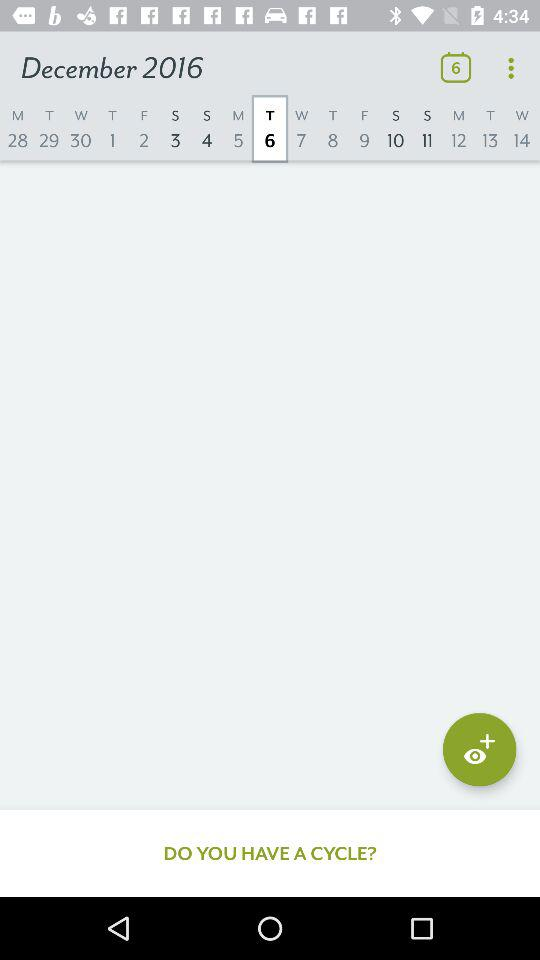What is the selected month? The selected month is December. 